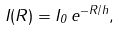<formula> <loc_0><loc_0><loc_500><loc_500>I ( R ) = I _ { 0 } \, e ^ { - R / h } ,</formula> 